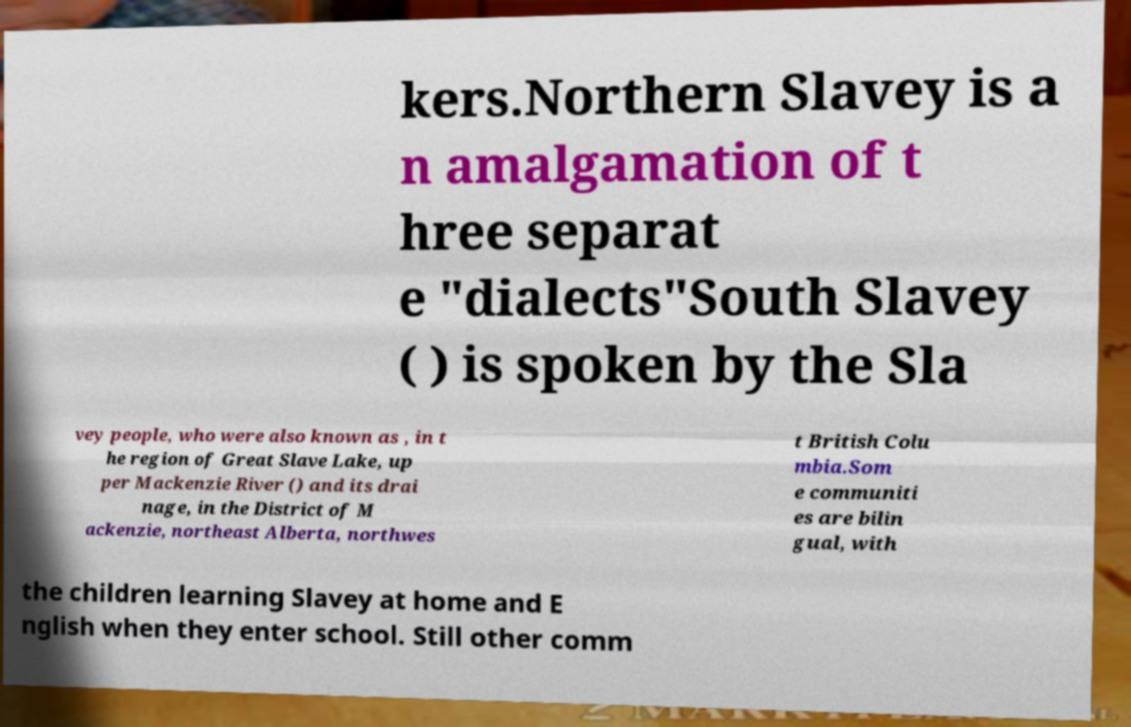I need the written content from this picture converted into text. Can you do that? kers.Northern Slavey is a n amalgamation of t hree separat e "dialects"South Slavey ( ) is spoken by the Sla vey people, who were also known as , in t he region of Great Slave Lake, up per Mackenzie River () and its drai nage, in the District of M ackenzie, northeast Alberta, northwes t British Colu mbia.Som e communiti es are bilin gual, with the children learning Slavey at home and E nglish when they enter school. Still other comm 